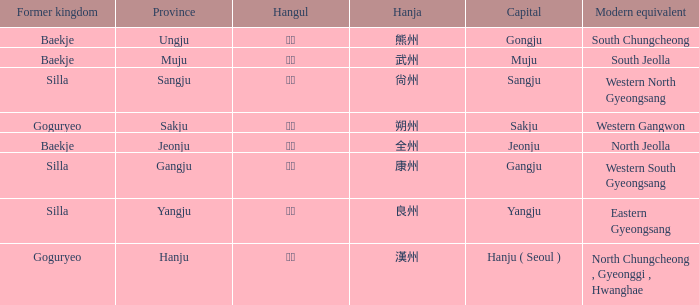How is the province of "sangju" written in hanja? 尙州. 